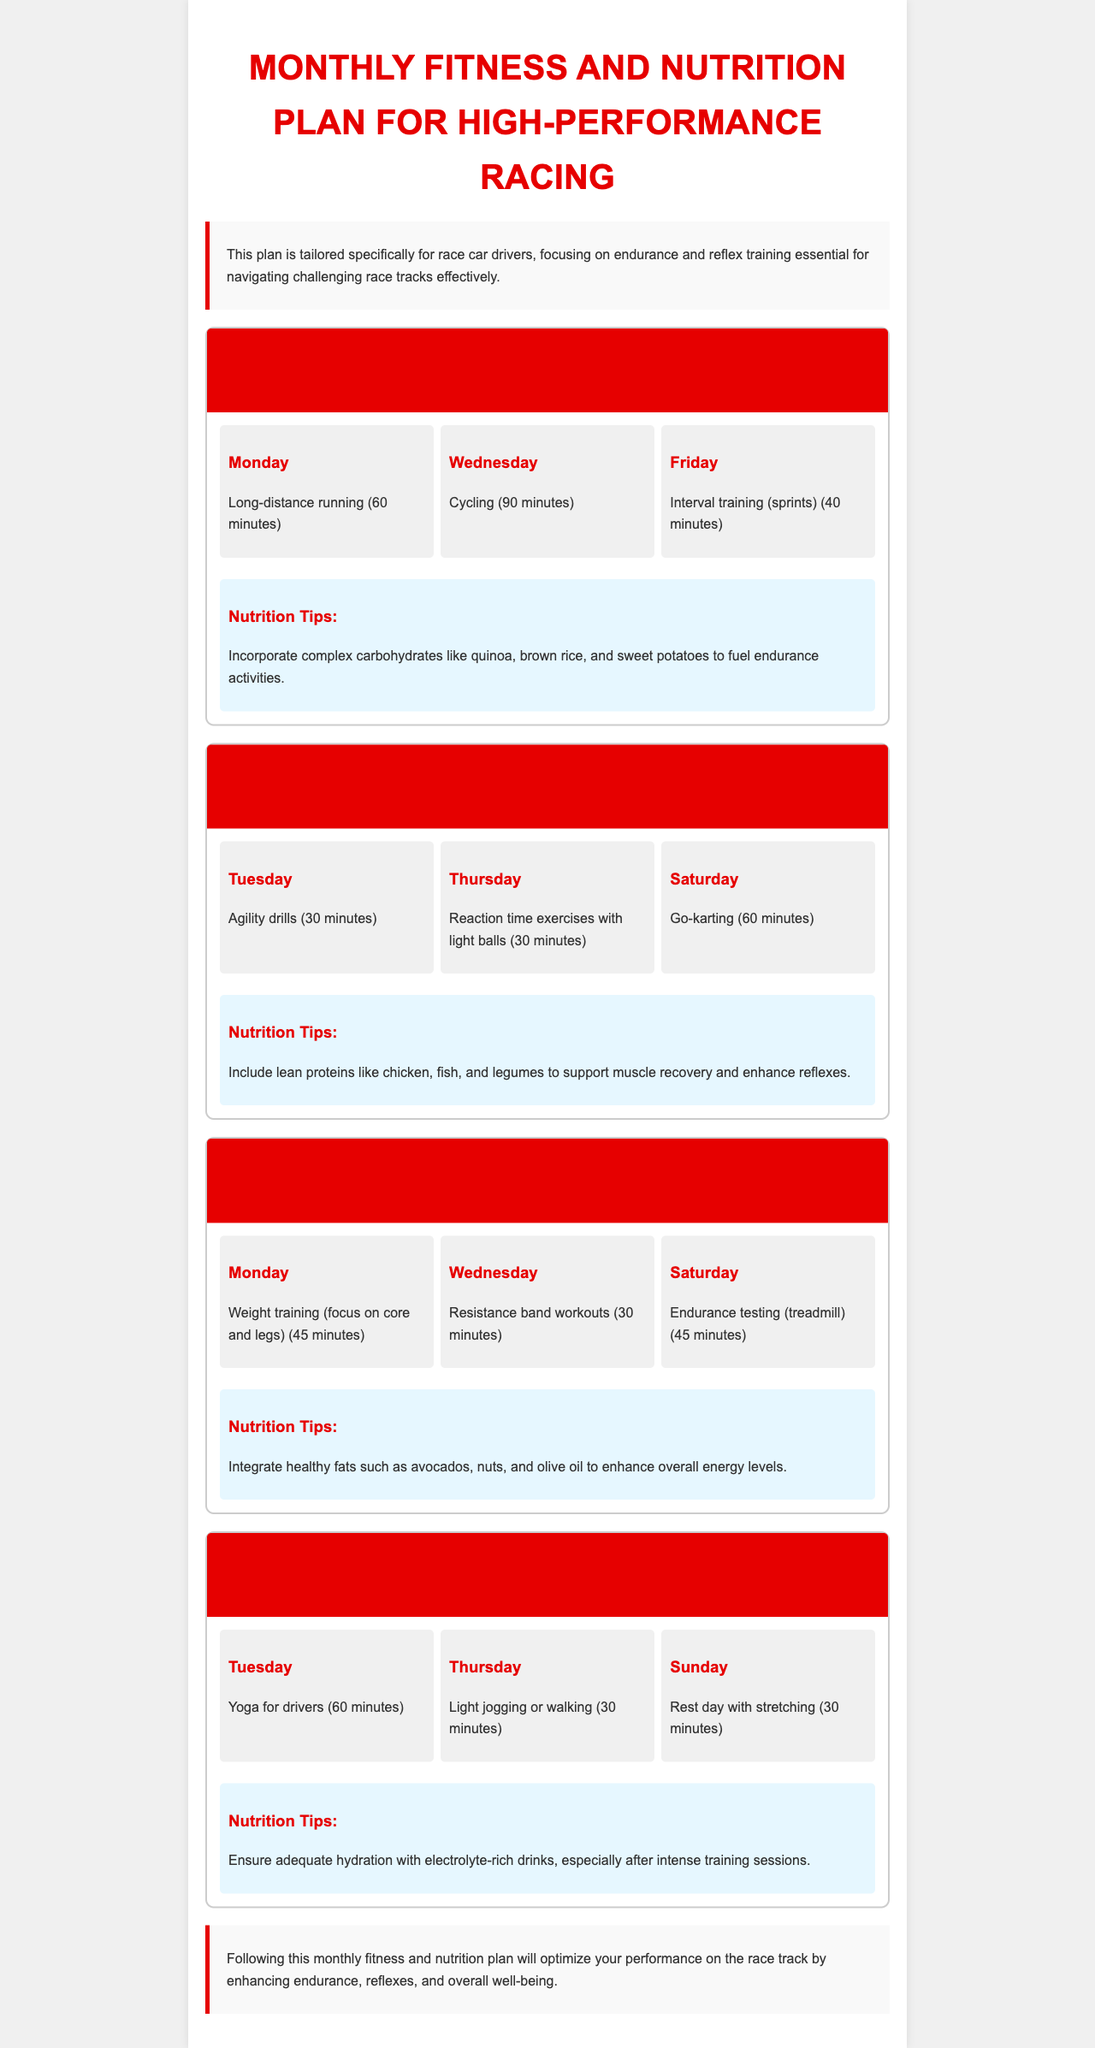What is the primary focus of the monthly plan? The primary focus of the monthly plan is to enhance endurance and reflex training for race car drivers.
Answer: endurance and reflex training How long is the long-distance running session on Monday of Week 1? The long-distance running session is scheduled for 60 minutes on Monday of Week 1.
Answer: 60 minutes Which day of Week 2 includes go-karting? Go-karting is scheduled for Saturday of Week 2.
Answer: Saturday What type of workouts are focused on in Week 3? Week 3 emphasizes strength training.
Answer: strength training What nutritional tip is suggested for Week 4? The nutritional tip for Week 4 suggests ensuring adequate hydration with electrolyte-rich drinks.
Answer: hydration with electrolyte-rich drinks How many days of workouts are planned in Week 2? There are three days of workouts planned in Week 2.
Answer: three days What exercise is recommended for Tuesday of Week 1? The recommended exercise for Tuesday of Week 1 is agility drills.
Answer: agility drills What is the overall theme of the conclusion? The overall theme of the conclusion emphasizes optimizing performance on the race track.
Answer: optimizing performance Which week focuses on nutrition related to recovery? Week 4 focuses on nutrition related to recovery.
Answer: Week 4 